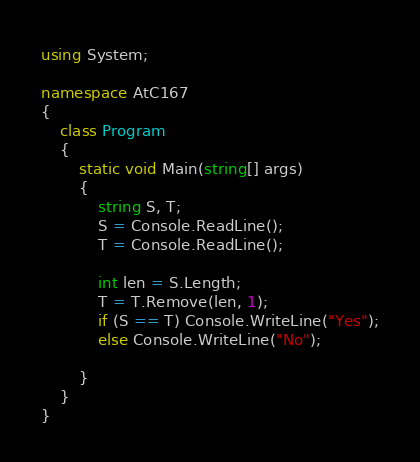Convert code to text. <code><loc_0><loc_0><loc_500><loc_500><_C#_>using System;

namespace AtC167
{
    class Program
    {
        static void Main(string[] args)
        {
            string S, T;
            S = Console.ReadLine();
            T = Console.ReadLine();

            int len = S.Length;
            T = T.Remove(len, 1);
            if (S == T) Console.WriteLine("Yes");
            else Console.WriteLine("No");

        }
    }
}
</code> 